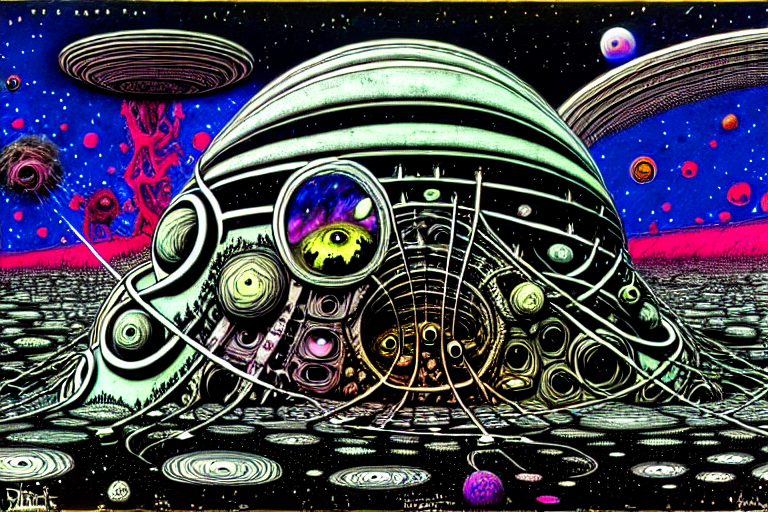What artistic style does this image represent? This image is indicative of a psychedelic or surrealist artistic style, characterized by vivid colors, dream-like scenes, and abstract elements that challenge conventional perceptions of reality. Can you explain the significance of the eye in the center of the structure? The eye often symbolizes perception, awareness, or a gateway into the soul or consciousness. In this context, it may represent a focal point of insight within a complex, otherworldly landscape, suggesting a narrative around observation or existential discovery. 